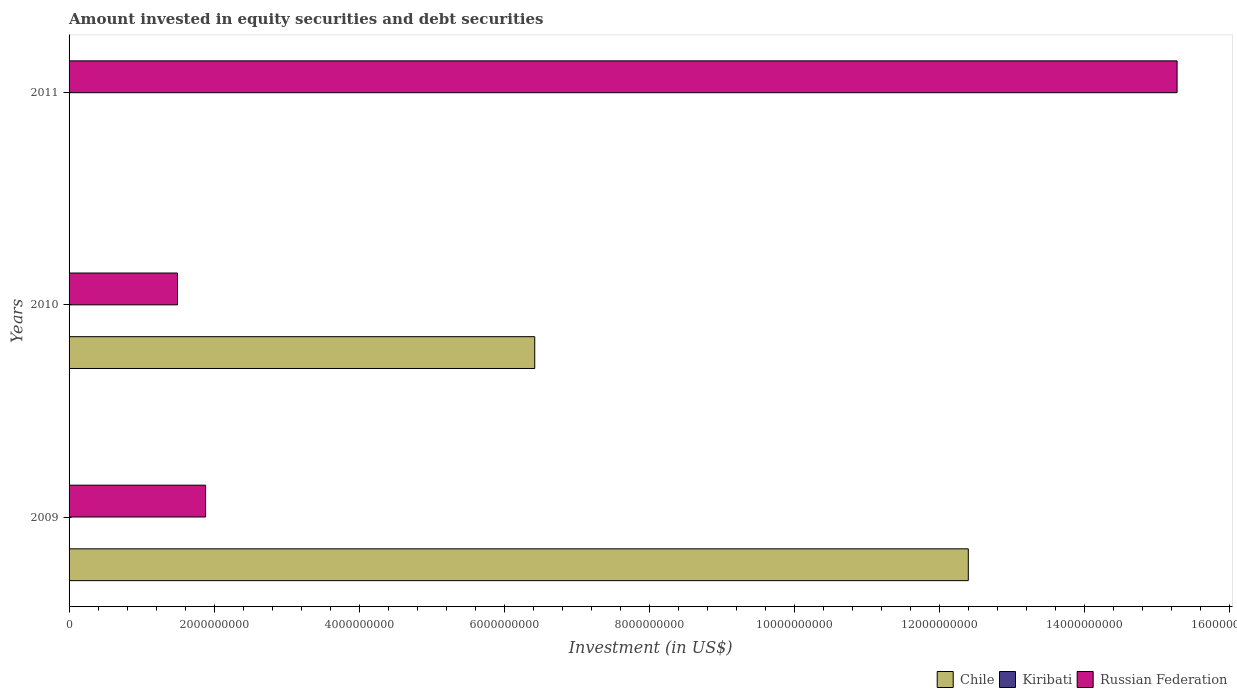What is the label of the 3rd group of bars from the top?
Your answer should be compact. 2009. In how many cases, is the number of bars for a given year not equal to the number of legend labels?
Give a very brief answer. 1. What is the amount invested in equity securities and debt securities in Kiribati in 2009?
Your answer should be very brief. 4.43e+06. Across all years, what is the maximum amount invested in equity securities and debt securities in Chile?
Your answer should be very brief. 1.24e+1. Across all years, what is the minimum amount invested in equity securities and debt securities in Kiribati?
Offer a terse response. 0. What is the total amount invested in equity securities and debt securities in Chile in the graph?
Your response must be concise. 1.88e+1. What is the difference between the amount invested in equity securities and debt securities in Kiribati in 2009 and that in 2010?
Offer a very short reply. 3.34e+06. What is the difference between the amount invested in equity securities and debt securities in Kiribati in 2010 and the amount invested in equity securities and debt securities in Russian Federation in 2009?
Offer a terse response. -1.88e+09. What is the average amount invested in equity securities and debt securities in Chile per year?
Offer a terse response. 6.27e+09. In the year 2010, what is the difference between the amount invested in equity securities and debt securities in Chile and amount invested in equity securities and debt securities in Russian Federation?
Ensure brevity in your answer.  4.93e+09. In how many years, is the amount invested in equity securities and debt securities in Chile greater than 5600000000 US$?
Give a very brief answer. 2. What is the ratio of the amount invested in equity securities and debt securities in Chile in 2009 to that in 2010?
Offer a very short reply. 1.93. Is the amount invested in equity securities and debt securities in Russian Federation in 2009 less than that in 2011?
Your answer should be compact. Yes. Is the difference between the amount invested in equity securities and debt securities in Chile in 2009 and 2010 greater than the difference between the amount invested in equity securities and debt securities in Russian Federation in 2009 and 2010?
Offer a very short reply. Yes. What is the difference between the highest and the second highest amount invested in equity securities and debt securities in Russian Federation?
Your answer should be very brief. 1.34e+1. What is the difference between the highest and the lowest amount invested in equity securities and debt securities in Chile?
Provide a succinct answer. 1.24e+1. In how many years, is the amount invested in equity securities and debt securities in Russian Federation greater than the average amount invested in equity securities and debt securities in Russian Federation taken over all years?
Give a very brief answer. 1. Is the sum of the amount invested in equity securities and debt securities in Russian Federation in 2010 and 2011 greater than the maximum amount invested in equity securities and debt securities in Chile across all years?
Ensure brevity in your answer.  Yes. Does the graph contain grids?
Your answer should be very brief. No. How are the legend labels stacked?
Offer a terse response. Horizontal. What is the title of the graph?
Provide a succinct answer. Amount invested in equity securities and debt securities. What is the label or title of the X-axis?
Give a very brief answer. Investment (in US$). What is the Investment (in US$) in Chile in 2009?
Your answer should be very brief. 1.24e+1. What is the Investment (in US$) of Kiribati in 2009?
Your answer should be compact. 4.43e+06. What is the Investment (in US$) in Russian Federation in 2009?
Give a very brief answer. 1.88e+09. What is the Investment (in US$) of Chile in 2010?
Give a very brief answer. 6.42e+09. What is the Investment (in US$) of Kiribati in 2010?
Make the answer very short. 1.10e+06. What is the Investment (in US$) of Russian Federation in 2010?
Ensure brevity in your answer.  1.50e+09. What is the Investment (in US$) of Russian Federation in 2011?
Your response must be concise. 1.53e+1. Across all years, what is the maximum Investment (in US$) in Chile?
Ensure brevity in your answer.  1.24e+1. Across all years, what is the maximum Investment (in US$) in Kiribati?
Offer a very short reply. 4.43e+06. Across all years, what is the maximum Investment (in US$) in Russian Federation?
Offer a terse response. 1.53e+1. Across all years, what is the minimum Investment (in US$) in Chile?
Provide a succinct answer. 0. Across all years, what is the minimum Investment (in US$) in Russian Federation?
Your answer should be compact. 1.50e+09. What is the total Investment (in US$) of Chile in the graph?
Offer a very short reply. 1.88e+1. What is the total Investment (in US$) in Kiribati in the graph?
Offer a very short reply. 5.53e+06. What is the total Investment (in US$) of Russian Federation in the graph?
Your answer should be compact. 1.87e+1. What is the difference between the Investment (in US$) in Chile in 2009 and that in 2010?
Ensure brevity in your answer.  5.98e+09. What is the difference between the Investment (in US$) in Kiribati in 2009 and that in 2010?
Provide a succinct answer. 3.34e+06. What is the difference between the Investment (in US$) in Russian Federation in 2009 and that in 2010?
Give a very brief answer. 3.87e+08. What is the difference between the Investment (in US$) in Russian Federation in 2009 and that in 2011?
Your answer should be very brief. -1.34e+1. What is the difference between the Investment (in US$) in Russian Federation in 2010 and that in 2011?
Your answer should be compact. -1.38e+1. What is the difference between the Investment (in US$) in Chile in 2009 and the Investment (in US$) in Kiribati in 2010?
Your response must be concise. 1.24e+1. What is the difference between the Investment (in US$) in Chile in 2009 and the Investment (in US$) in Russian Federation in 2010?
Offer a terse response. 1.09e+1. What is the difference between the Investment (in US$) in Kiribati in 2009 and the Investment (in US$) in Russian Federation in 2010?
Ensure brevity in your answer.  -1.49e+09. What is the difference between the Investment (in US$) in Chile in 2009 and the Investment (in US$) in Russian Federation in 2011?
Your answer should be very brief. -2.88e+09. What is the difference between the Investment (in US$) in Kiribati in 2009 and the Investment (in US$) in Russian Federation in 2011?
Your answer should be very brief. -1.53e+1. What is the difference between the Investment (in US$) in Chile in 2010 and the Investment (in US$) in Russian Federation in 2011?
Give a very brief answer. -8.86e+09. What is the difference between the Investment (in US$) of Kiribati in 2010 and the Investment (in US$) of Russian Federation in 2011?
Ensure brevity in your answer.  -1.53e+1. What is the average Investment (in US$) in Chile per year?
Make the answer very short. 6.27e+09. What is the average Investment (in US$) of Kiribati per year?
Provide a succinct answer. 1.84e+06. What is the average Investment (in US$) in Russian Federation per year?
Make the answer very short. 6.22e+09. In the year 2009, what is the difference between the Investment (in US$) of Chile and Investment (in US$) of Kiribati?
Offer a very short reply. 1.24e+1. In the year 2009, what is the difference between the Investment (in US$) in Chile and Investment (in US$) in Russian Federation?
Offer a very short reply. 1.05e+1. In the year 2009, what is the difference between the Investment (in US$) in Kiribati and Investment (in US$) in Russian Federation?
Offer a very short reply. -1.88e+09. In the year 2010, what is the difference between the Investment (in US$) of Chile and Investment (in US$) of Kiribati?
Ensure brevity in your answer.  6.42e+09. In the year 2010, what is the difference between the Investment (in US$) in Chile and Investment (in US$) in Russian Federation?
Make the answer very short. 4.93e+09. In the year 2010, what is the difference between the Investment (in US$) of Kiribati and Investment (in US$) of Russian Federation?
Give a very brief answer. -1.49e+09. What is the ratio of the Investment (in US$) of Chile in 2009 to that in 2010?
Your response must be concise. 1.93. What is the ratio of the Investment (in US$) in Kiribati in 2009 to that in 2010?
Your response must be concise. 4.05. What is the ratio of the Investment (in US$) in Russian Federation in 2009 to that in 2010?
Keep it short and to the point. 1.26. What is the ratio of the Investment (in US$) of Russian Federation in 2009 to that in 2011?
Give a very brief answer. 0.12. What is the ratio of the Investment (in US$) in Russian Federation in 2010 to that in 2011?
Offer a terse response. 0.1. What is the difference between the highest and the second highest Investment (in US$) in Russian Federation?
Give a very brief answer. 1.34e+1. What is the difference between the highest and the lowest Investment (in US$) of Chile?
Your response must be concise. 1.24e+1. What is the difference between the highest and the lowest Investment (in US$) in Kiribati?
Make the answer very short. 4.43e+06. What is the difference between the highest and the lowest Investment (in US$) of Russian Federation?
Your response must be concise. 1.38e+1. 